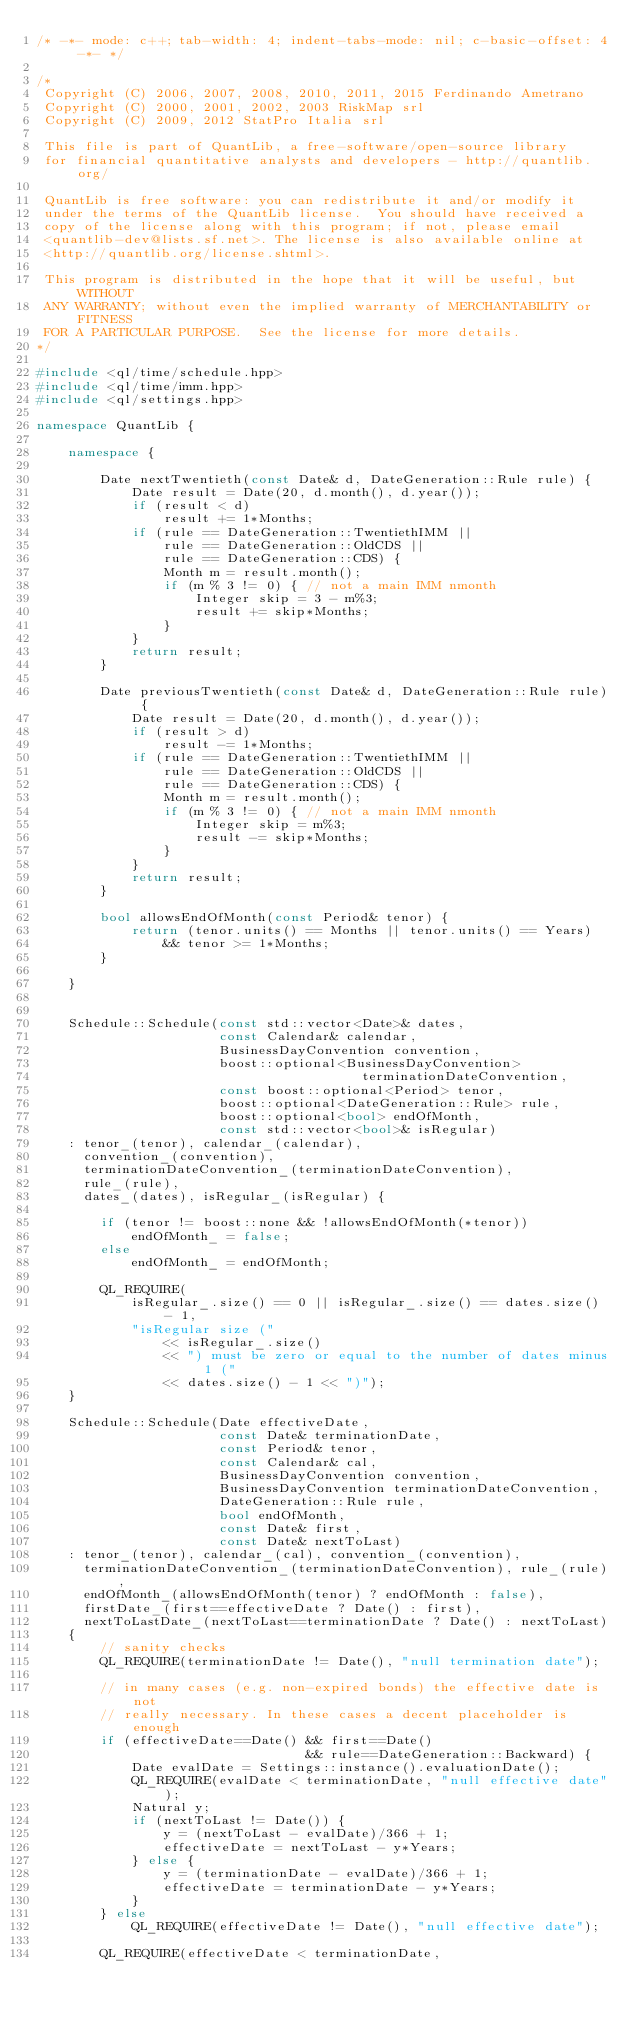Convert code to text. <code><loc_0><loc_0><loc_500><loc_500><_C++_>/* -*- mode: c++; tab-width: 4; indent-tabs-mode: nil; c-basic-offset: 4 -*- */

/*
 Copyright (C) 2006, 2007, 2008, 2010, 2011, 2015 Ferdinando Ametrano
 Copyright (C) 2000, 2001, 2002, 2003 RiskMap srl
 Copyright (C) 2009, 2012 StatPro Italia srl

 This file is part of QuantLib, a free-software/open-source library
 for financial quantitative analysts and developers - http://quantlib.org/

 QuantLib is free software: you can redistribute it and/or modify it
 under the terms of the QuantLib license.  You should have received a
 copy of the license along with this program; if not, please email
 <quantlib-dev@lists.sf.net>. The license is also available online at
 <http://quantlib.org/license.shtml>.

 This program is distributed in the hope that it will be useful, but WITHOUT
 ANY WARRANTY; without even the implied warranty of MERCHANTABILITY or FITNESS
 FOR A PARTICULAR PURPOSE.  See the license for more details.
*/

#include <ql/time/schedule.hpp>
#include <ql/time/imm.hpp>
#include <ql/settings.hpp>

namespace QuantLib {

    namespace {

        Date nextTwentieth(const Date& d, DateGeneration::Rule rule) {
            Date result = Date(20, d.month(), d.year());
            if (result < d)
                result += 1*Months;
            if (rule == DateGeneration::TwentiethIMM ||
                rule == DateGeneration::OldCDS ||
                rule == DateGeneration::CDS) {
                Month m = result.month();
                if (m % 3 != 0) { // not a main IMM nmonth
                    Integer skip = 3 - m%3;
                    result += skip*Months;
                }
            }
            return result;
        }

        Date previousTwentieth(const Date& d, DateGeneration::Rule rule) {
            Date result = Date(20, d.month(), d.year());
            if (result > d)
                result -= 1*Months;
            if (rule == DateGeneration::TwentiethIMM ||
                rule == DateGeneration::OldCDS ||
                rule == DateGeneration::CDS) {
                Month m = result.month();
                if (m % 3 != 0) { // not a main IMM nmonth
                    Integer skip = m%3;
                    result -= skip*Months;
                }
            }
            return result;
        }

        bool allowsEndOfMonth(const Period& tenor) {
            return (tenor.units() == Months || tenor.units() == Years)
                && tenor >= 1*Months;
        }

    }


    Schedule::Schedule(const std::vector<Date>& dates,
                       const Calendar& calendar,
                       BusinessDayConvention convention,
                       boost::optional<BusinessDayConvention>
                                         terminationDateConvention,
                       const boost::optional<Period> tenor,
                       boost::optional<DateGeneration::Rule> rule,
                       boost::optional<bool> endOfMonth,
                       const std::vector<bool>& isRegular)
    : tenor_(tenor), calendar_(calendar),
      convention_(convention),
      terminationDateConvention_(terminationDateConvention),
      rule_(rule),
      dates_(dates), isRegular_(isRegular) {

        if (tenor != boost::none && !allowsEndOfMonth(*tenor))
            endOfMonth_ = false;
        else
            endOfMonth_ = endOfMonth;

        QL_REQUIRE(
            isRegular_.size() == 0 || isRegular_.size() == dates.size() - 1,
            "isRegular size ("
                << isRegular_.size()
                << ") must be zero or equal to the number of dates minus 1 ("
                << dates.size() - 1 << ")");
    }

    Schedule::Schedule(Date effectiveDate,
                       const Date& terminationDate,
                       const Period& tenor,
                       const Calendar& cal,
                       BusinessDayConvention convention,
                       BusinessDayConvention terminationDateConvention,
                       DateGeneration::Rule rule,
                       bool endOfMonth,
                       const Date& first,
                       const Date& nextToLast)
    : tenor_(tenor), calendar_(cal), convention_(convention),
      terminationDateConvention_(terminationDateConvention), rule_(rule),
      endOfMonth_(allowsEndOfMonth(tenor) ? endOfMonth : false),
      firstDate_(first==effectiveDate ? Date() : first),
      nextToLastDate_(nextToLast==terminationDate ? Date() : nextToLast)
    {
        // sanity checks
        QL_REQUIRE(terminationDate != Date(), "null termination date");

        // in many cases (e.g. non-expired bonds) the effective date is not
        // really necessary. In these cases a decent placeholder is enough
        if (effectiveDate==Date() && first==Date()
                                  && rule==DateGeneration::Backward) {
            Date evalDate = Settings::instance().evaluationDate();
            QL_REQUIRE(evalDate < terminationDate, "null effective date");
            Natural y;
            if (nextToLast != Date()) {
                y = (nextToLast - evalDate)/366 + 1;
                effectiveDate = nextToLast - y*Years;
            } else {
                y = (terminationDate - evalDate)/366 + 1;
                effectiveDate = terminationDate - y*Years;
            }
        } else
            QL_REQUIRE(effectiveDate != Date(), "null effective date");

        QL_REQUIRE(effectiveDate < terminationDate,</code> 